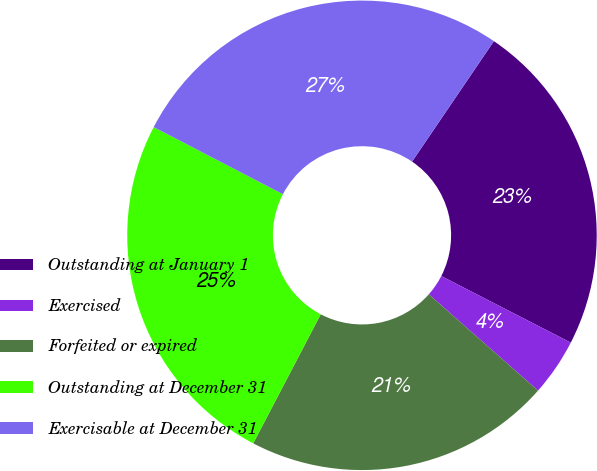Convert chart to OTSL. <chart><loc_0><loc_0><loc_500><loc_500><pie_chart><fcel>Outstanding at January 1<fcel>Exercised<fcel>Forfeited or expired<fcel>Outstanding at December 31<fcel>Exercisable at December 31<nl><fcel>23.06%<fcel>3.95%<fcel>21.16%<fcel>24.96%<fcel>26.87%<nl></chart> 